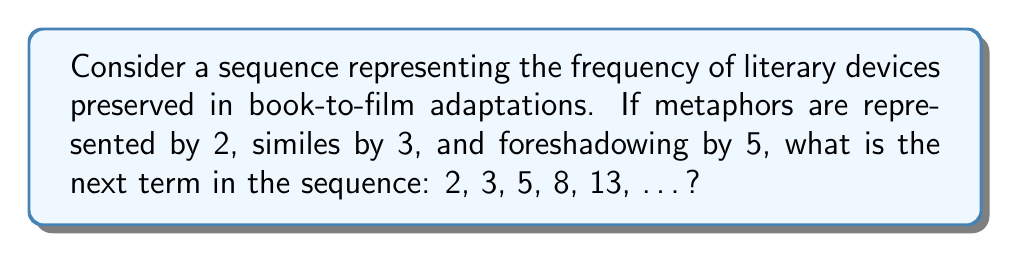Solve this math problem. To determine the next term in this sequence, we need to analyze the pattern:

1. First, let's look at the differences between consecutive terms:
   $2 \rightarrow 3$ (difference of 1)
   $3 \rightarrow 5$ (difference of 2)
   $5 \rightarrow 8$ (difference of 3)
   $8 \rightarrow 13$ (difference of 5)

2. We can observe that the differences themselves form a sequence: 1, 2, 3, 5, ...

3. This sequence of differences is actually the Fibonacci sequence, where each term is the sum of the two preceding ones.

4. Therefore, we can conclude that our original sequence is the Fibonacci sequence offset by one term.

5. To find the next term, we add the last two terms:
   $13 + 8 = 21$

6. This pattern reflects the cumulative nature of literary devices in adaptations, where each new element builds upon the previous ones, much like how a meticulous editor would ensure that the essence of the book is preserved and enhanced in the film adaptation.
Answer: 21 